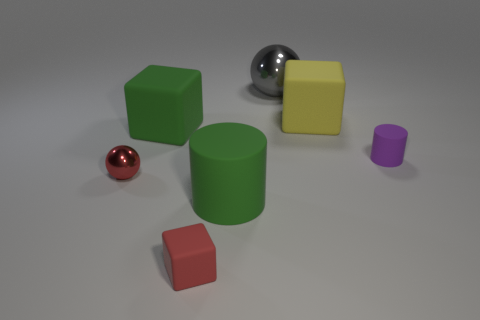Subtract all big rubber cubes. How many cubes are left? 1 Add 3 big green matte objects. How many objects exist? 10 Subtract all red blocks. How many blocks are left? 2 Subtract all cylinders. How many objects are left? 5 Subtract 1 cylinders. How many cylinders are left? 1 Subtract all red spheres. Subtract all green cylinders. How many spheres are left? 1 Subtract all brown cylinders. How many red spheres are left? 1 Subtract all big blue metal blocks. Subtract all large metal things. How many objects are left? 6 Add 3 big green rubber objects. How many big green rubber objects are left? 5 Add 6 tiny shiny objects. How many tiny shiny objects exist? 7 